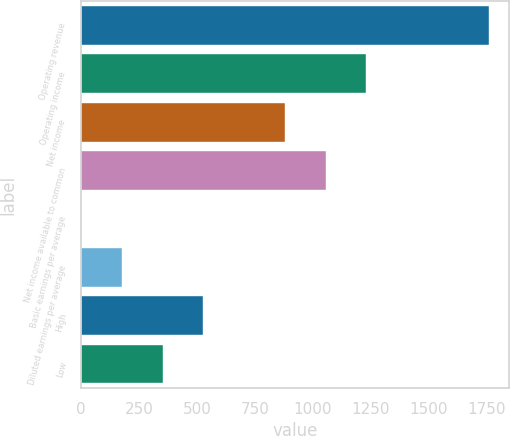<chart> <loc_0><loc_0><loc_500><loc_500><bar_chart><fcel>Operating revenue<fcel>Operating income<fcel>Net income<fcel>Net income available to common<fcel>Basic earnings per average<fcel>Diluted earnings per average<fcel>High<fcel>Low<nl><fcel>1758<fcel>1230.69<fcel>879.16<fcel>1054.92<fcel>0.35<fcel>176.12<fcel>527.64<fcel>351.88<nl></chart> 